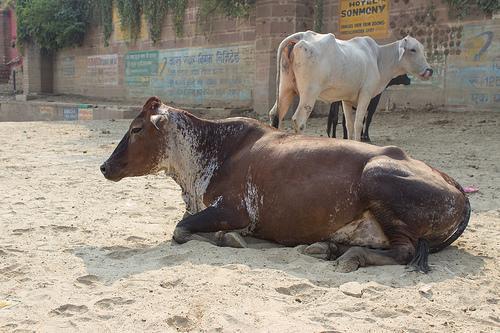How many white cows?
Give a very brief answer. 1. 